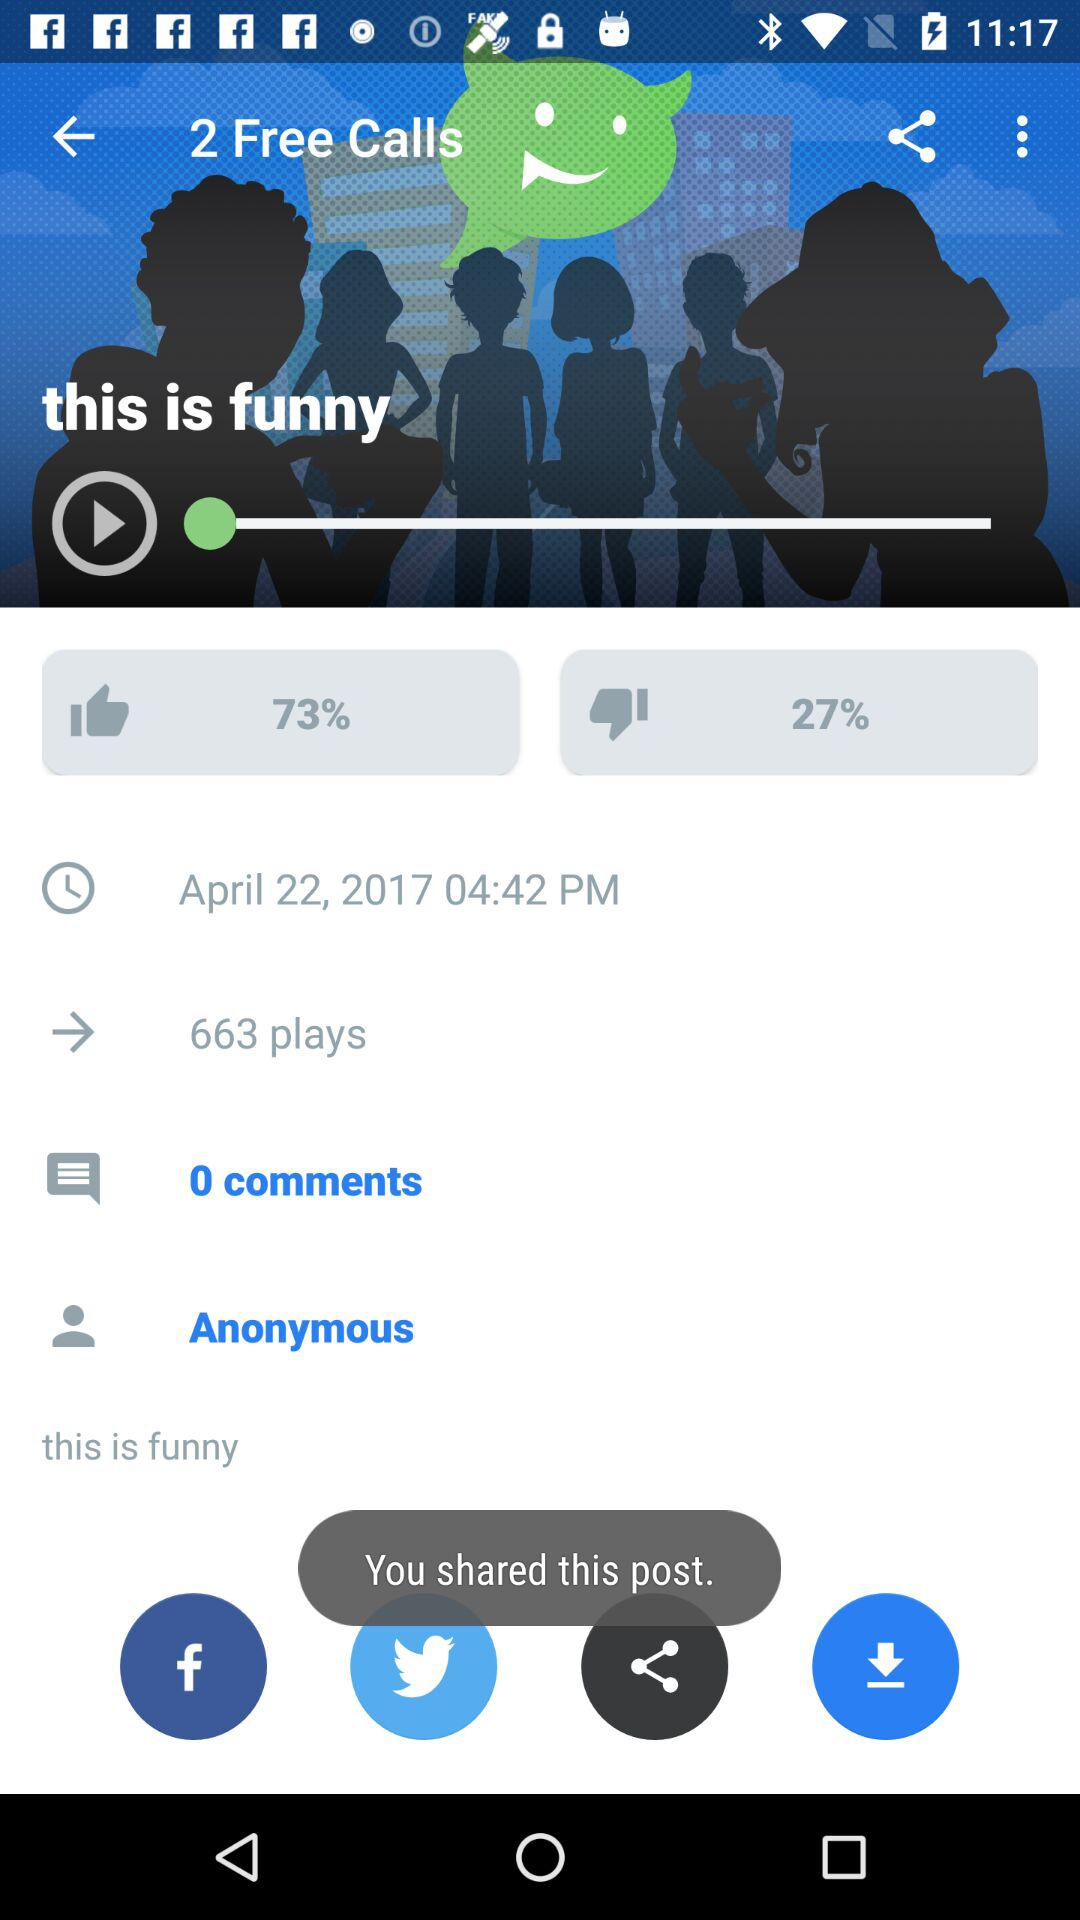What is the total number of comments? The total number of comments is 0. 